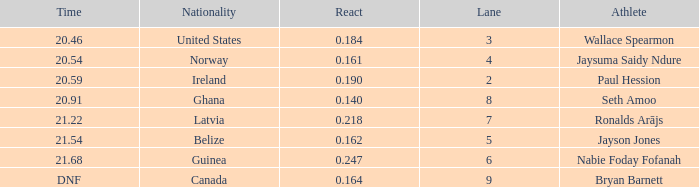What is the lowest lane when react is more than 0.164 and the nationality is guinea? 6.0. 